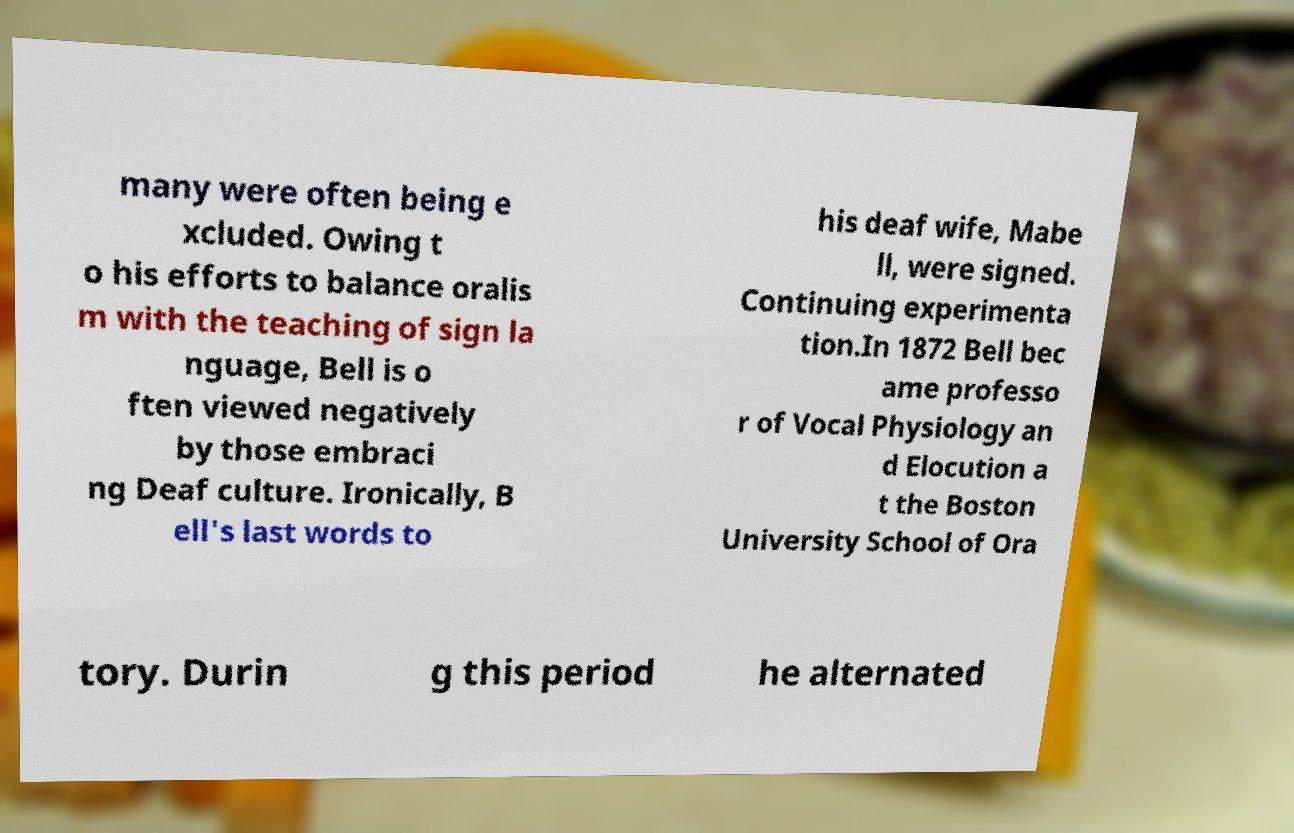There's text embedded in this image that I need extracted. Can you transcribe it verbatim? many were often being e xcluded. Owing t o his efforts to balance oralis m with the teaching of sign la nguage, Bell is o ften viewed negatively by those embraci ng Deaf culture. Ironically, B ell's last words to his deaf wife, Mabe ll, were signed. Continuing experimenta tion.In 1872 Bell bec ame professo r of Vocal Physiology an d Elocution a t the Boston University School of Ora tory. Durin g this period he alternated 